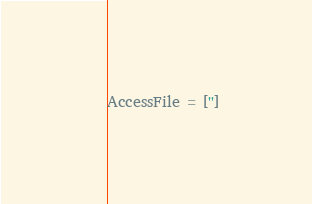<code> <loc_0><loc_0><loc_500><loc_500><_Python_>AccessFile = ['']</code> 